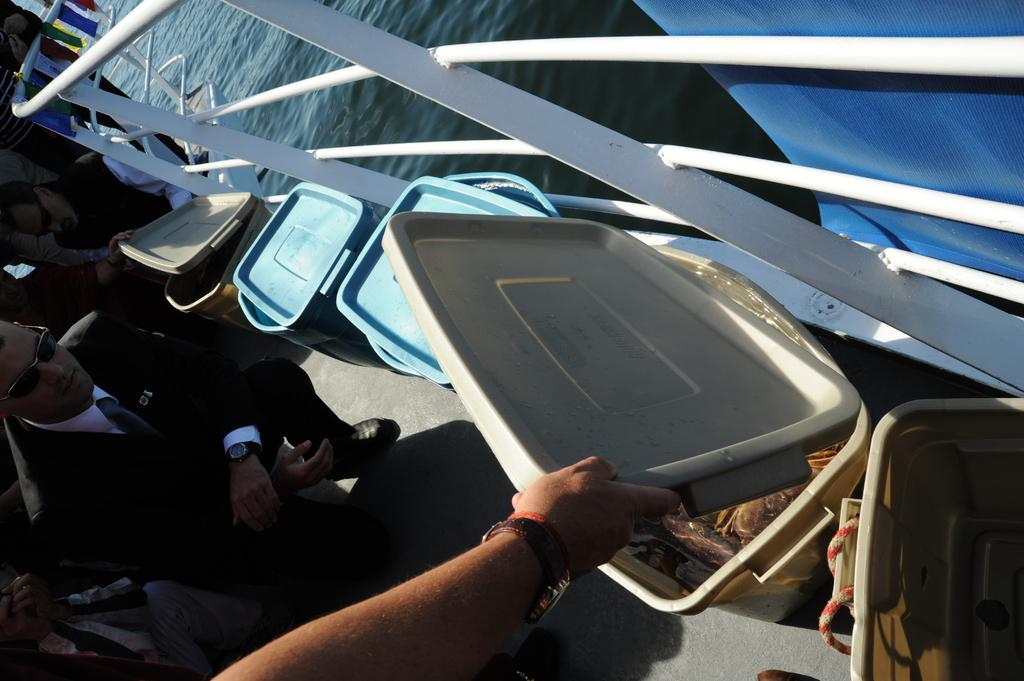What is the main subject of the image? There is a group of people in the image. What objects are present in the image besides the people? There are boxes with lids in the image. Where are the boxes located? The boxes are on a ship. What is the ship's location in the image? The ship is on water. What type of blade can be seen cutting through the powder in the image? There is no blade or powder present in the image. 